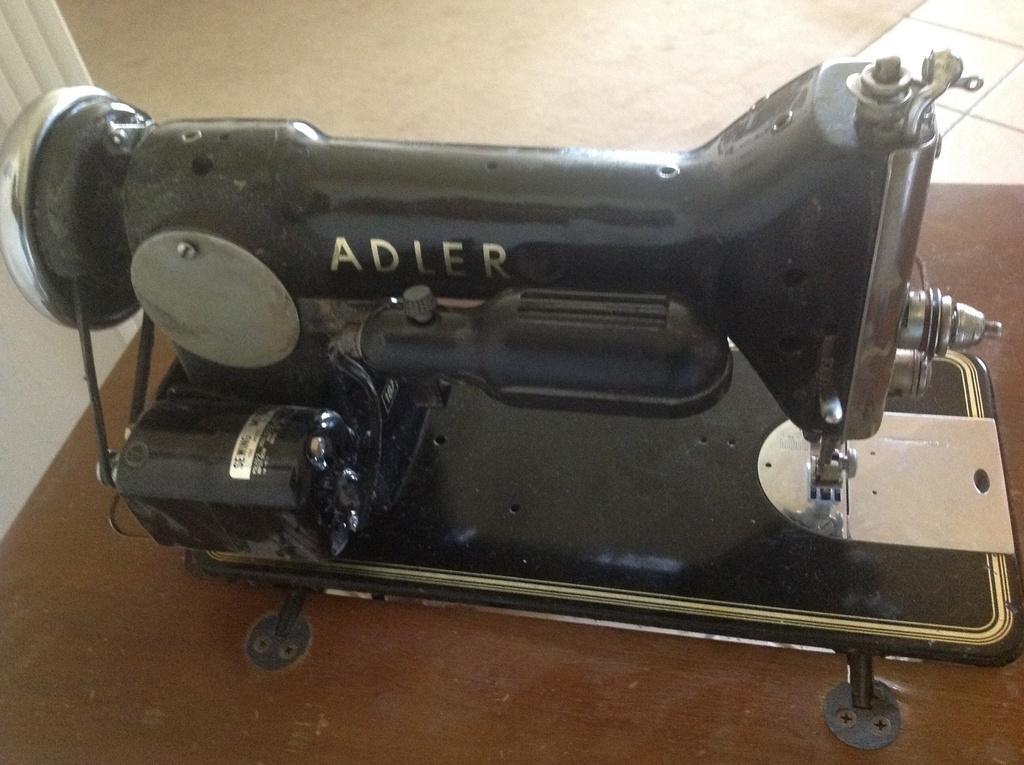In one or two sentences, can you explain what this image depicts? In the center of the image we can see sewing machine placed on the table. In the background there is a floor. 